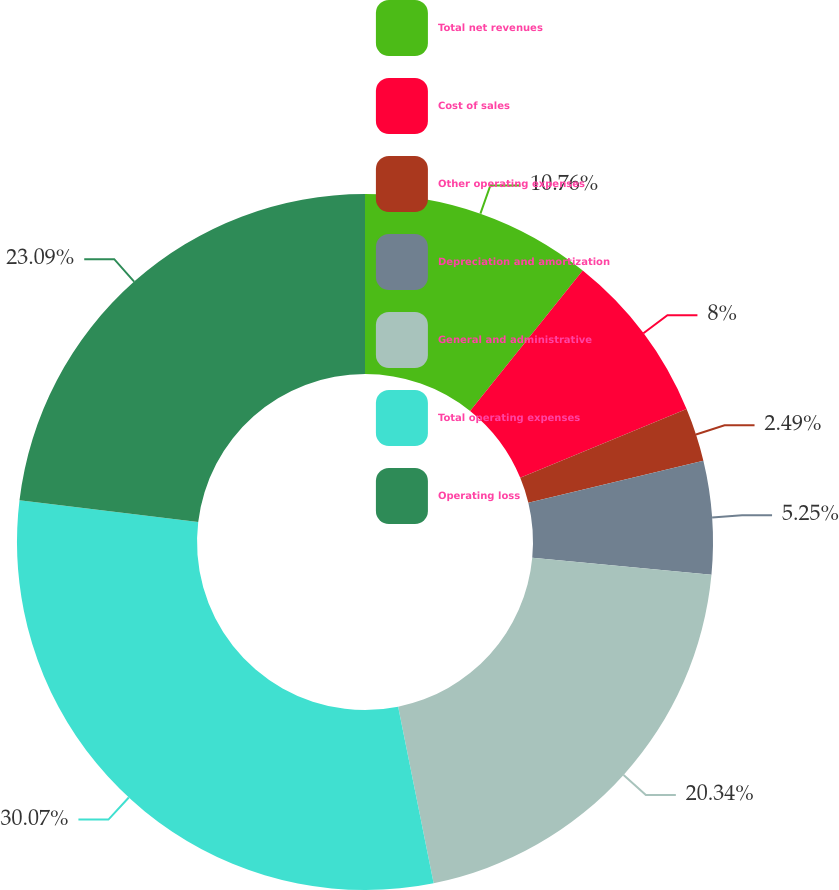Convert chart to OTSL. <chart><loc_0><loc_0><loc_500><loc_500><pie_chart><fcel>Total net revenues<fcel>Cost of sales<fcel>Other operating expenses<fcel>Depreciation and amortization<fcel>General and administrative<fcel>Total operating expenses<fcel>Operating loss<nl><fcel>10.76%<fcel>8.0%<fcel>2.49%<fcel>5.25%<fcel>20.34%<fcel>30.07%<fcel>23.09%<nl></chart> 